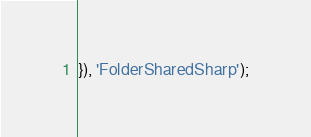Convert code to text. <code><loc_0><loc_0><loc_500><loc_500><_JavaScript_>}), 'FolderSharedSharp');</code> 